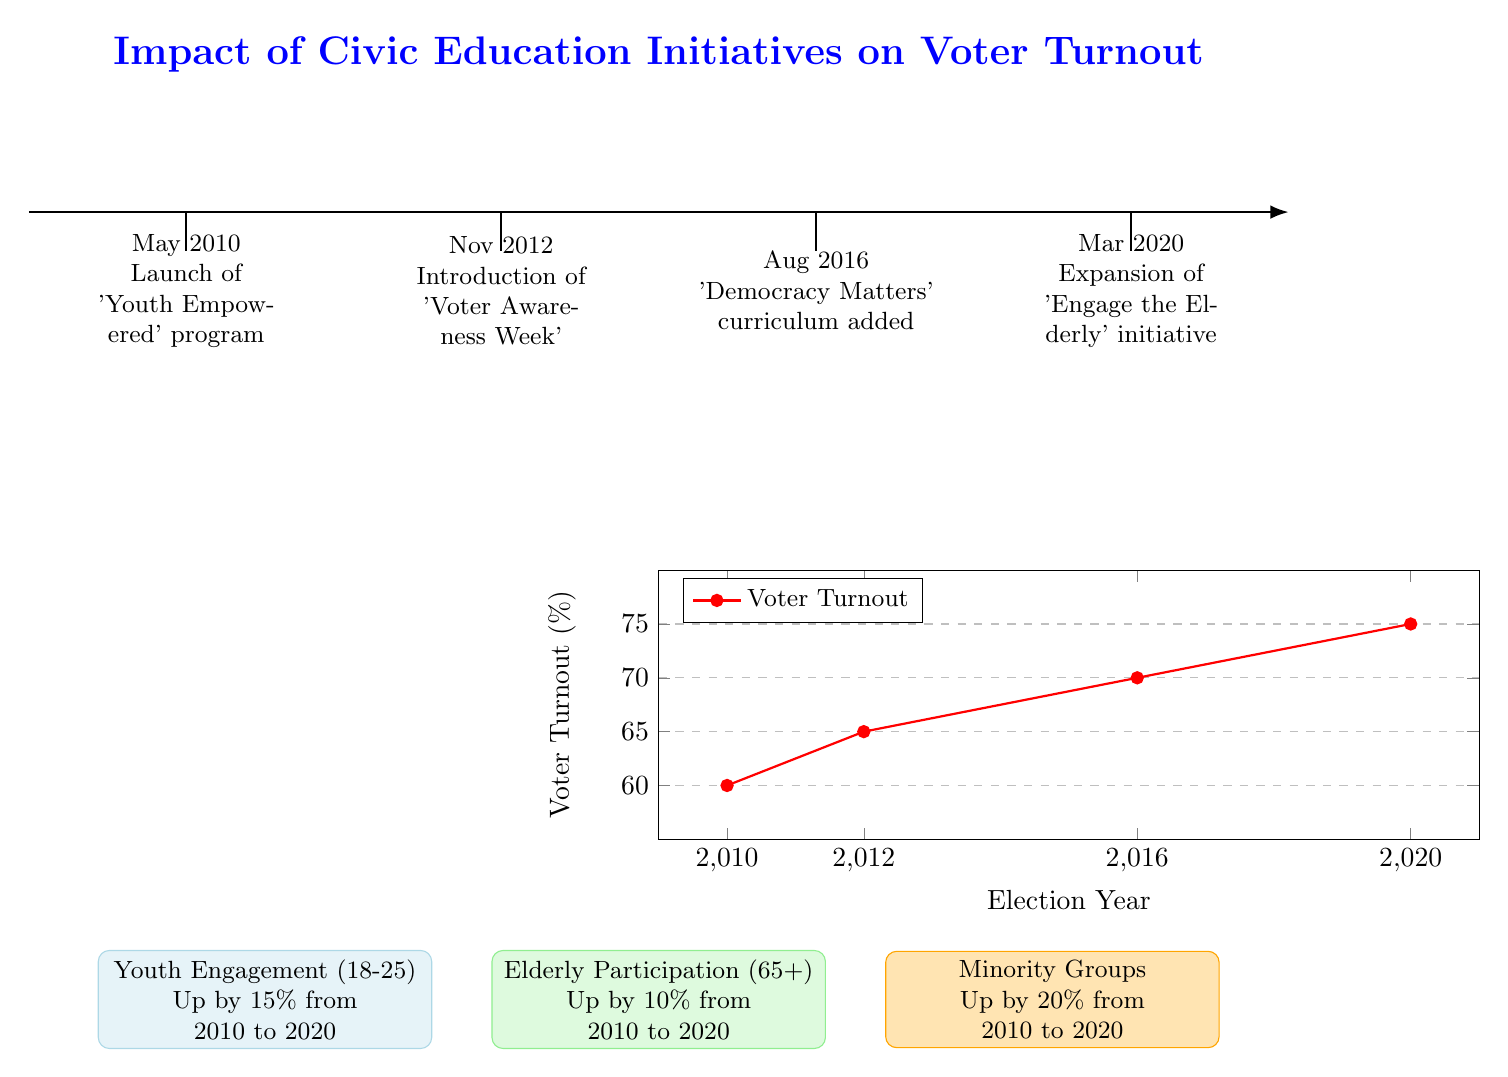What civic education initiative was launched in May 2010? The diagram states that the 'Youth Empowered' program was launched in May 2010 as the first initiative shown on the timeline.
Answer: Youth Empowered What was the voter turnout percentage in 2016? Looking at the voter turnout graph, the data point for the year 2016 indicates a turnout percentage of 70%.
Answer: 70 How many civic education initiatives are represented in the diagram? The timeline lists a total of four civic education initiatives implemented from 2010 to 2020.
Answer: Four What demographic showed a 20% increase in participation from 2010 to 2020? Based on the demographics impact section, Minority Groups experienced a 20% increase in participation over the specified period.
Answer: Minority Groups Which year had the highest voter turnout percentage? By examining the voter turnout data, the graph shows that the highest percentage of voter turnout occurred in the year 2020 at 75%.
Answer: 2020 What was the percentage increase in voter turnout from 2010 to 2020? The voter turnout increased from 60% in 2010 to 75% in 2020, which counts as a 15% increase over the span of a decade.
Answer: 15% What initiative was introduced in November 2012? According to the timeline features, the 'Voter Awareness Week' initiative was introduced in November 2012.
Answer: Voter Awareness Week What demographics saw a 10% increase in voter turnout? The diagram highlights that Elderly Participation (65+) increased by 10% from 2010 to 2020.
Answer: Elderly Participation What color represents Youth Engagement in the demographic impacts? The demographic impact concerning Youth Engagement is represented in light blue color coding on the diagram.
Answer: Light blue 